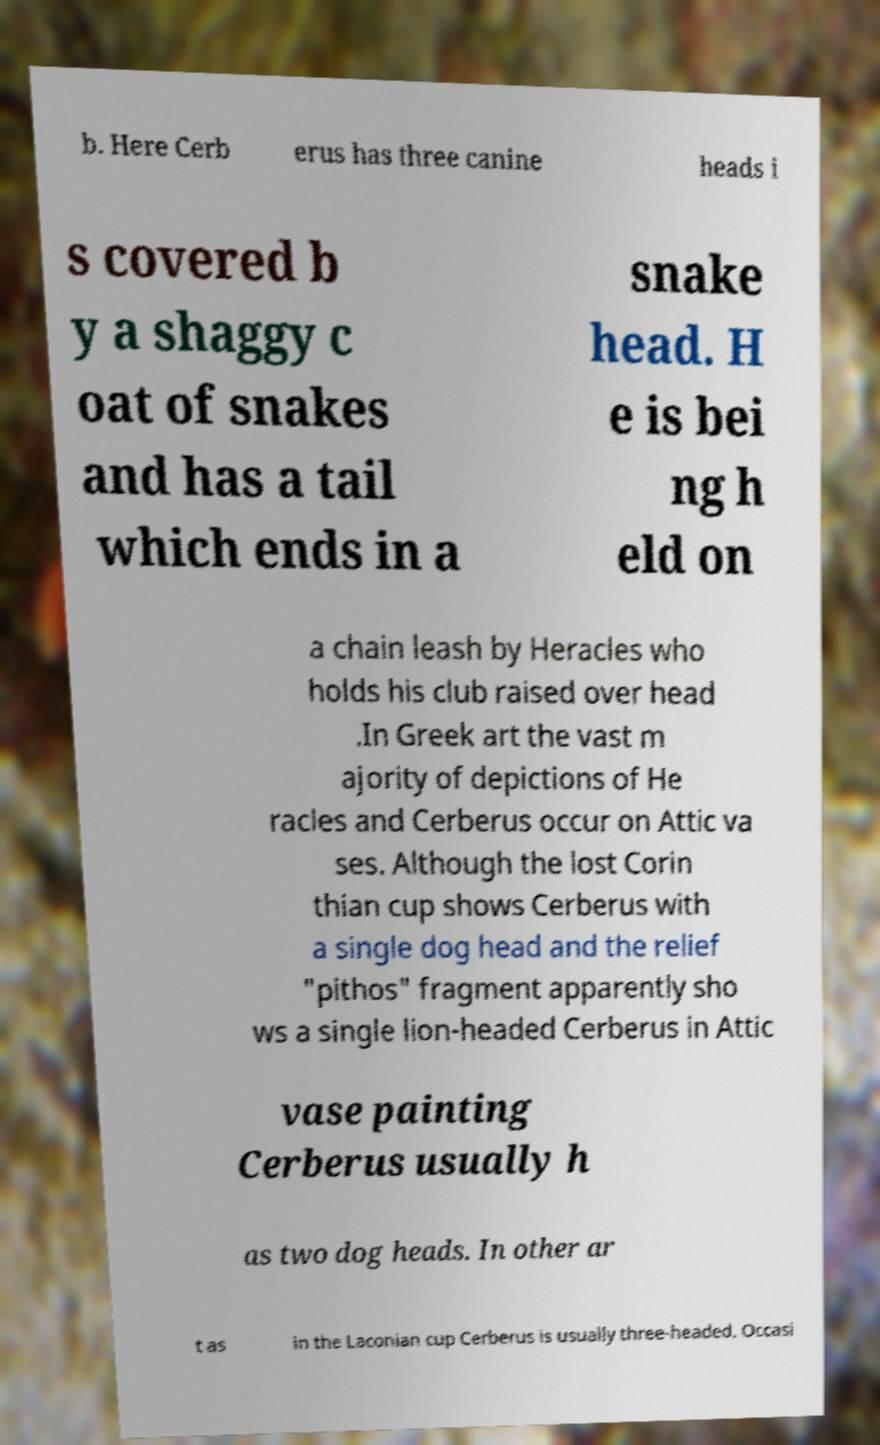Please identify and transcribe the text found in this image. b. Here Cerb erus has three canine heads i s covered b y a shaggy c oat of snakes and has a tail which ends in a snake head. H e is bei ng h eld on a chain leash by Heracles who holds his club raised over head .In Greek art the vast m ajority of depictions of He racles and Cerberus occur on Attic va ses. Although the lost Corin thian cup shows Cerberus with a single dog head and the relief "pithos" fragment apparently sho ws a single lion-headed Cerberus in Attic vase painting Cerberus usually h as two dog heads. In other ar t as in the Laconian cup Cerberus is usually three-headed. Occasi 